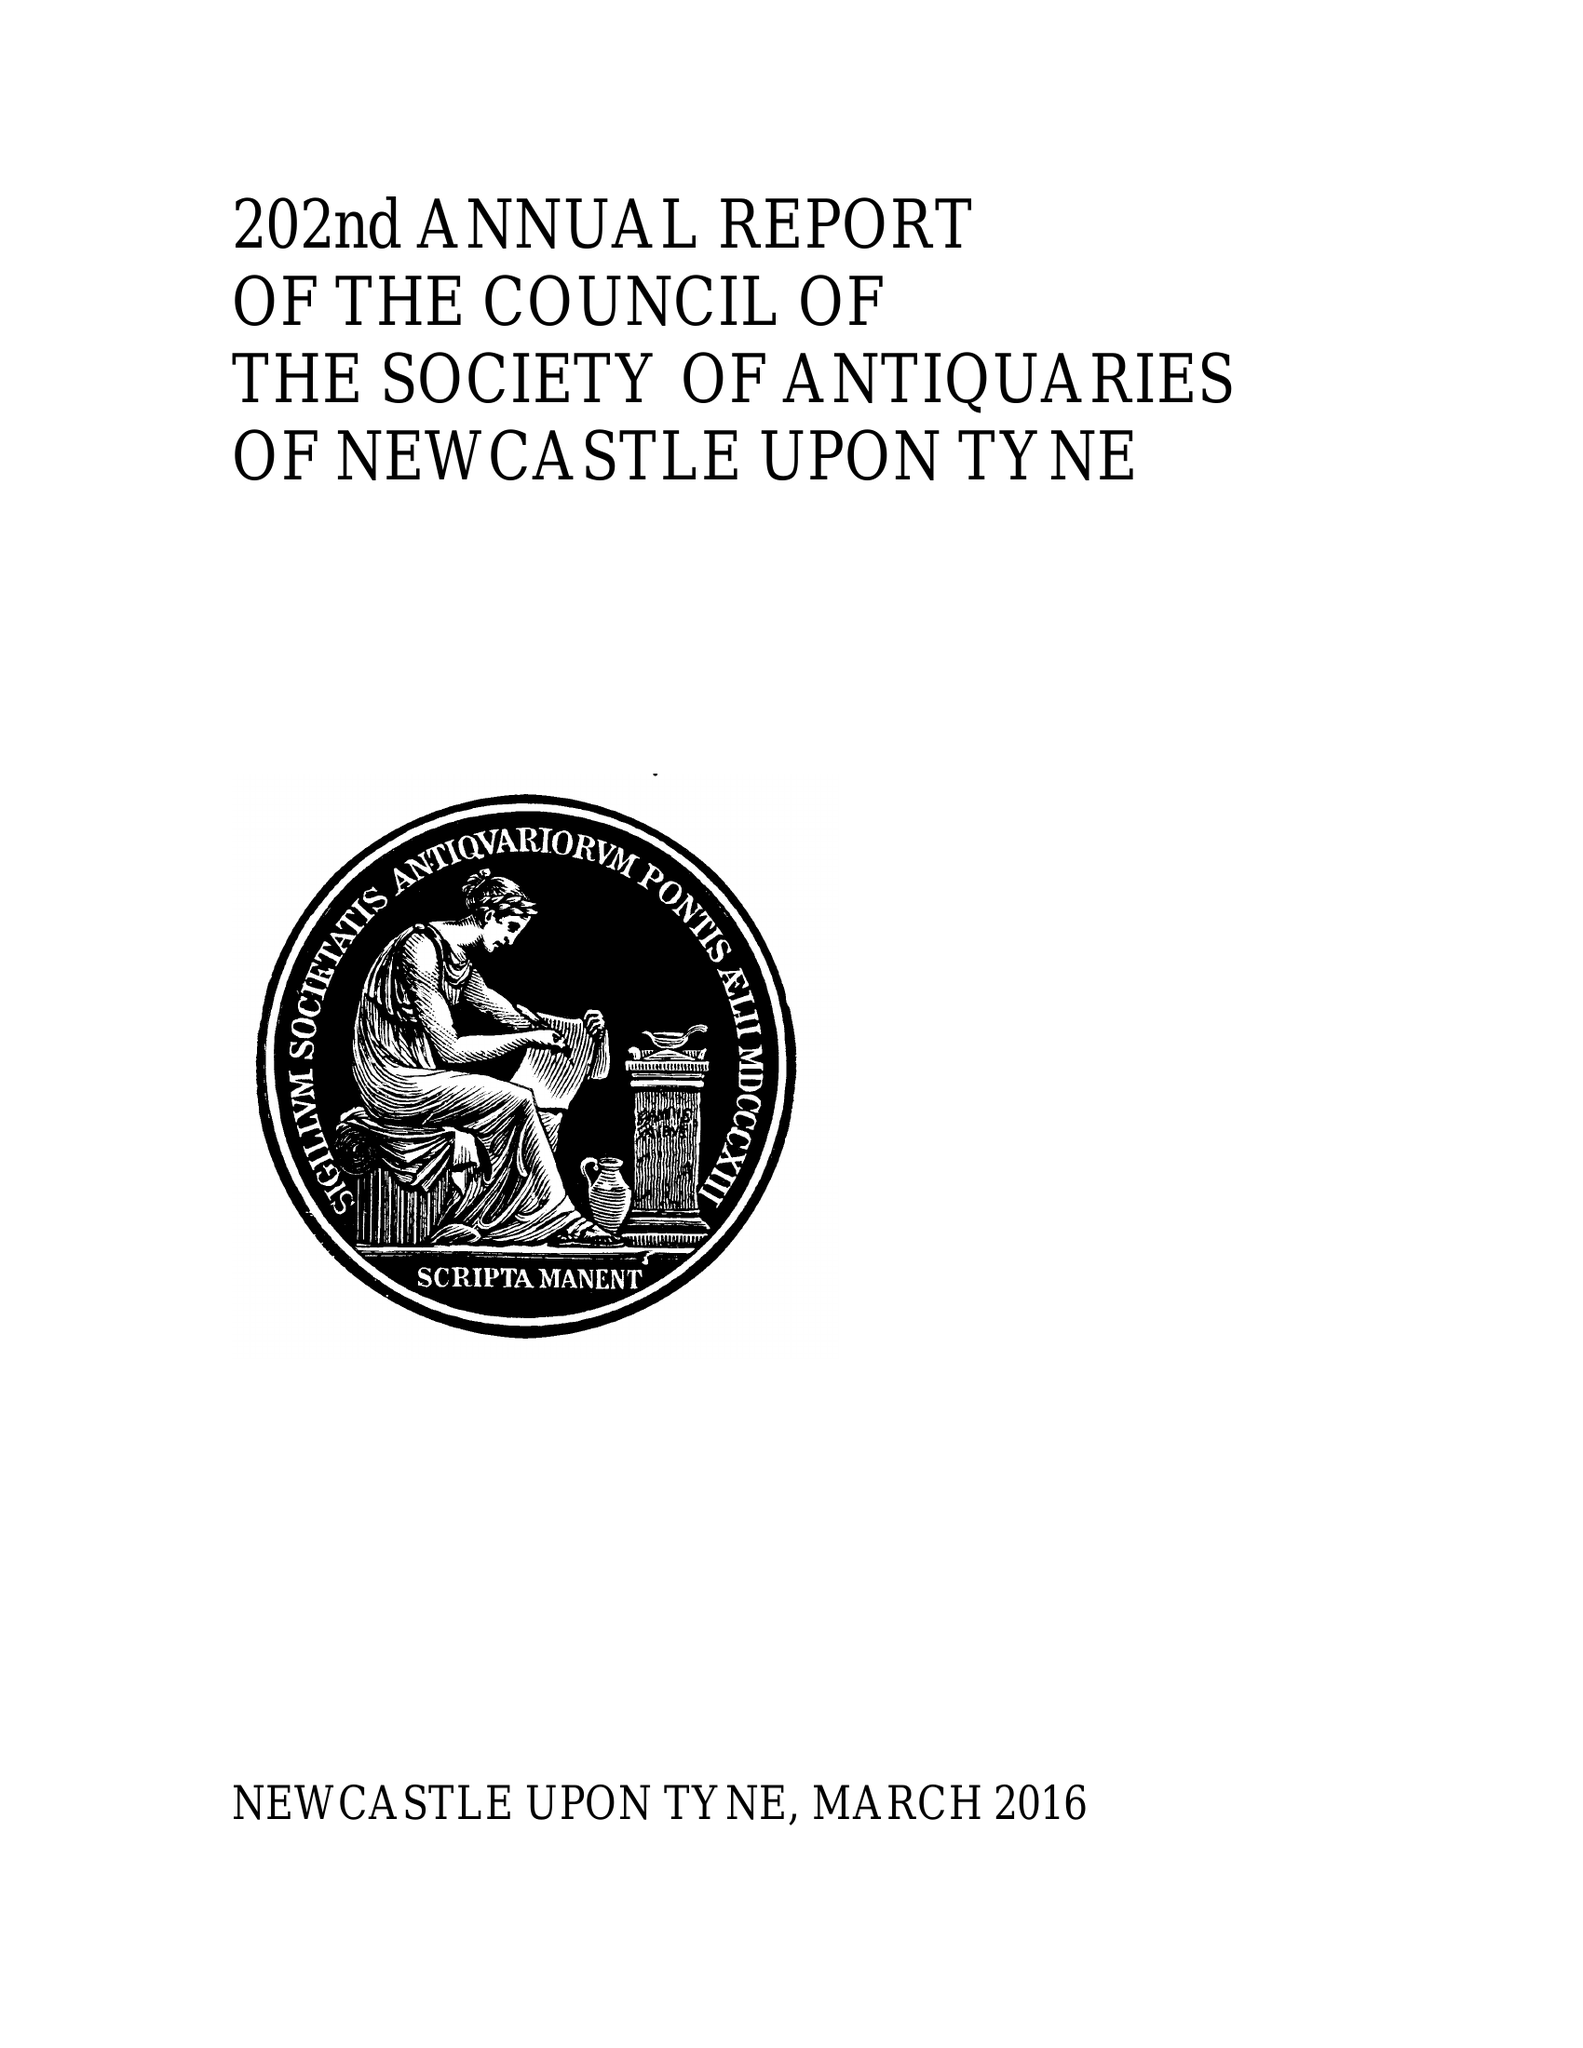What is the value for the report_date?
Answer the question using a single word or phrase. 2015-12-31 